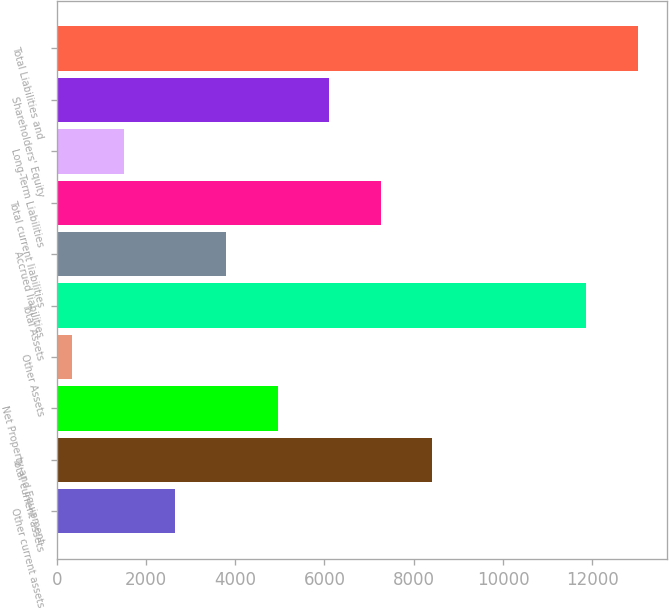Convert chart to OTSL. <chart><loc_0><loc_0><loc_500><loc_500><bar_chart><fcel>Other current assets<fcel>Total current assets<fcel>Net Property and Equipment<fcel>Other Assets<fcel>Total Assets<fcel>Accrued liabilities<fcel>Total current liabilities<fcel>Long-Term Liabilities<fcel>Shareholders' Equity<fcel>Total Liabilities and<nl><fcel>2651.2<fcel>8409.2<fcel>4954.4<fcel>348<fcel>11864<fcel>3802.8<fcel>7257.6<fcel>1499.6<fcel>6106<fcel>13015.6<nl></chart> 